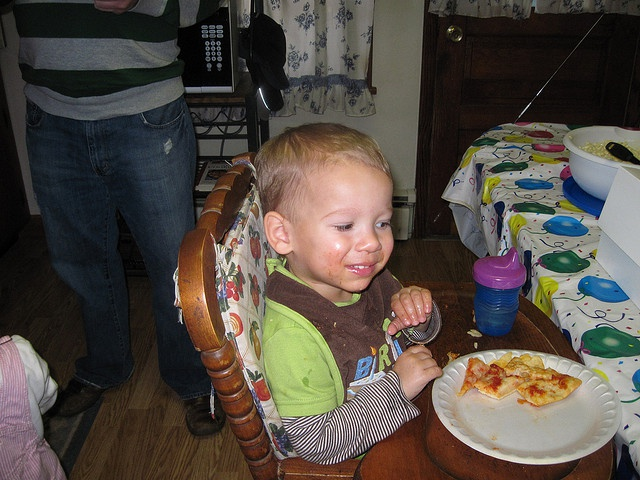Describe the objects in this image and their specific colors. I can see people in black, gray, and darkblue tones, people in black, lightpink, maroon, tan, and gray tones, dining table in black, darkgray, maroon, and tan tones, dining table in black, darkgray, gray, and darkgreen tones, and chair in black, maroon, darkgray, and gray tones in this image. 